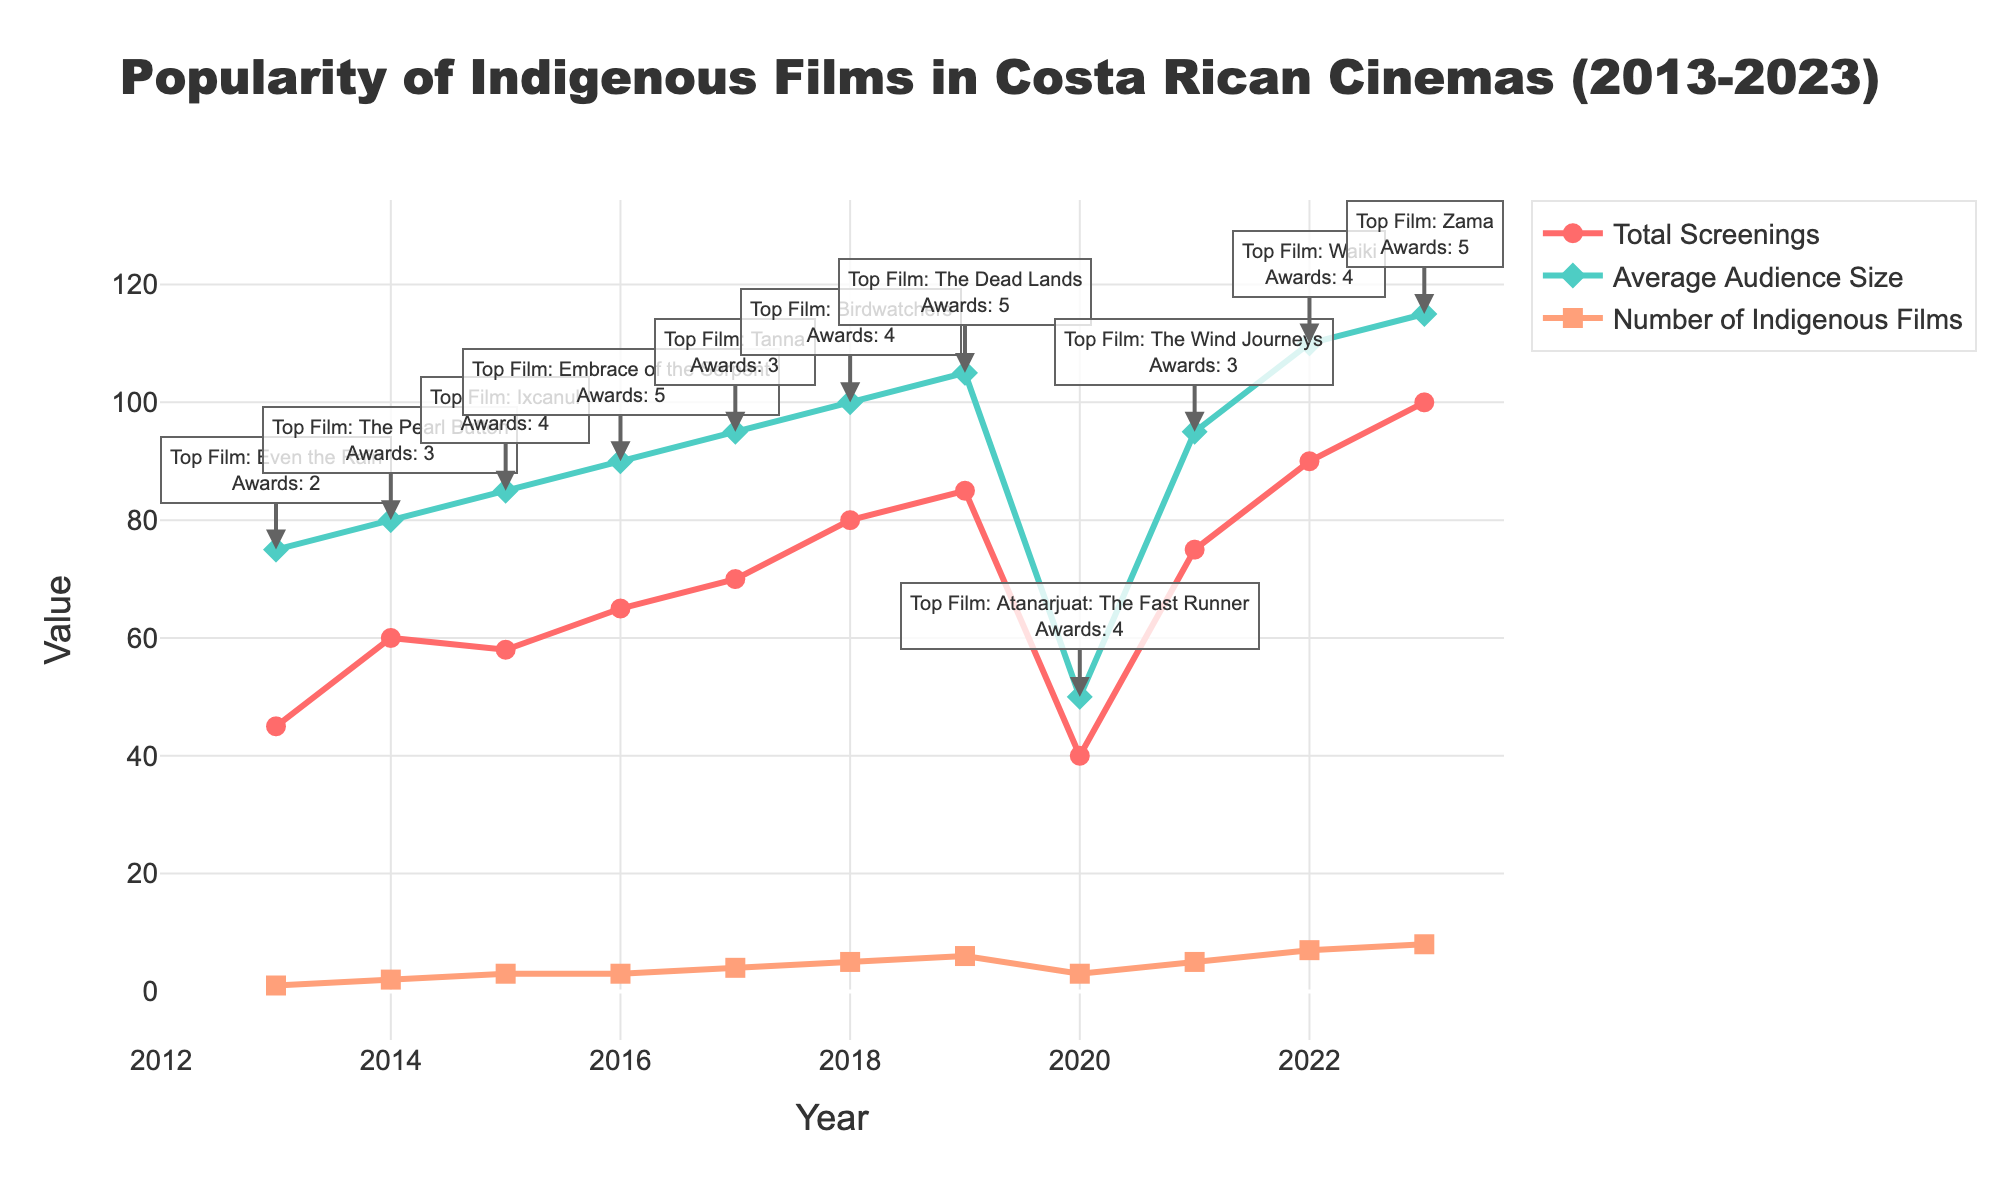What's the title of the plot? The title of the plot is located at the top and center of the figure and describes the main subject of the plot.
Answer: Popularity of Indigenous Films in Costa Rican Cinemas (2013-2023) How many indigenous films were shown in 2022? Look at the orange line segment with square markers corresponding to the year 2022 on the x-axis. Read the value of the y-axis for the “Number of Indigenous Films”.
Answer: 7 How did the total screenings change from 2013 to 2020? Compare the value of the red line with circle markers for the years 2013 and 2020. Note the decrease in the y-axis values.
Answer: Decreased from 45 to 40 Which year had the highest average audience size? Find the peak value on the green line with diamond markers. Observe which year corresponds to this highest y-axis value.
Answer: 2023 What's the total number of awards won in 2020? Check the annotation for 2020 and identify the number of awards mentioned in the annotation text.
Answer: 4 What was the top indigenous film in 2016? Read the annotation text for the year 2016 to find the "Top Film" mentioned.
Answer: Embrace of the Serpent Compare the average audience size in 2017 and 2021. Which year had a higher average audience size? Find and compare the values on the green line for the years 2017 and 2021.
Answer: 2022 Calculate the increase in the number of indigenous films from 2013 to 2023. Subtract the 2013 value on the orange line from the 2023 value on the same line to find the increase.
Answer: 7 What is the trend in the total screenings from 2018 to 2023? Observe the red line from 2018 to 2023 to identify if it is increasing, decreasing, or remaining constant.
Answer: Increasing How many awards were won by indigenous films in 2019? Check the annotation for 2019 and identify the number of awards mentioned in the annotation text.
Answer: 5 